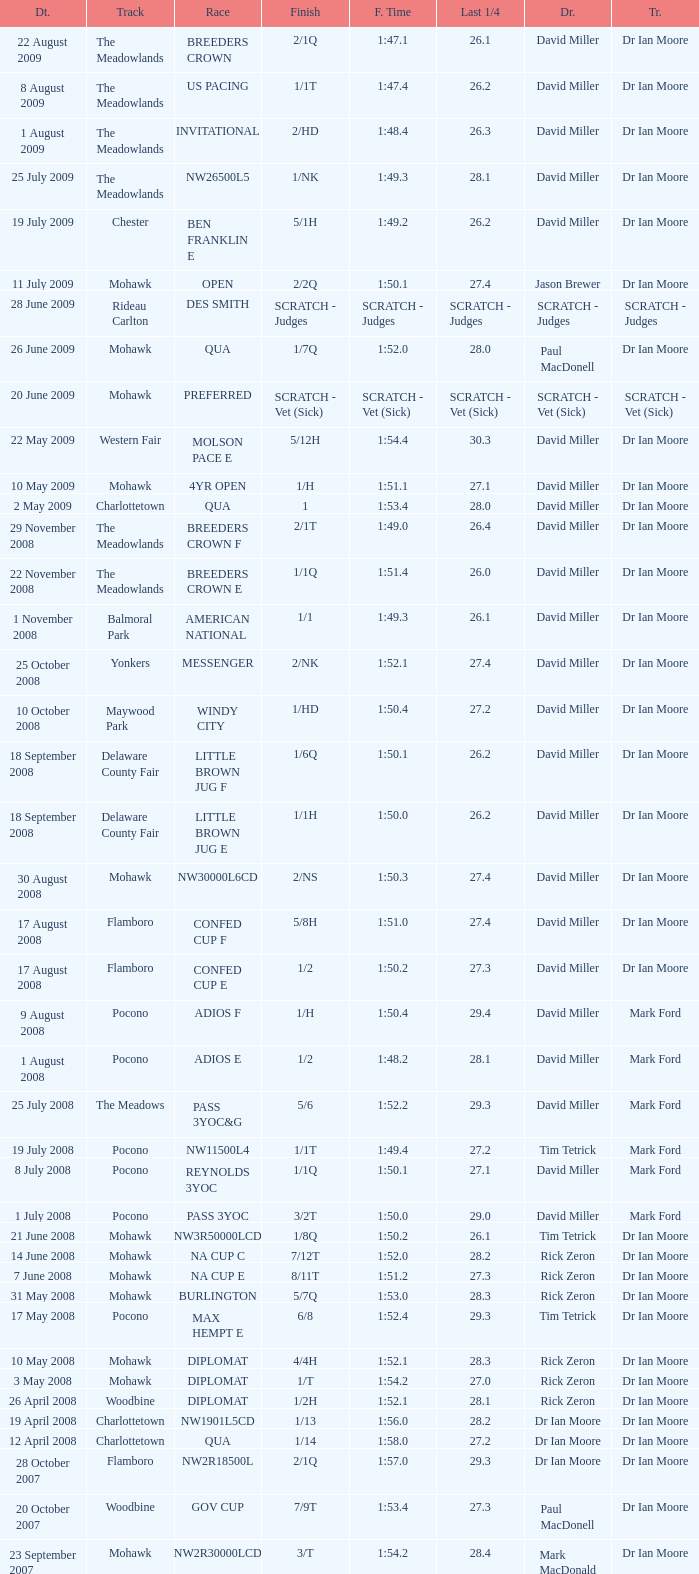What is the finishing time with a 2/1q finish on the Meadowlands track? 1:47.1. 